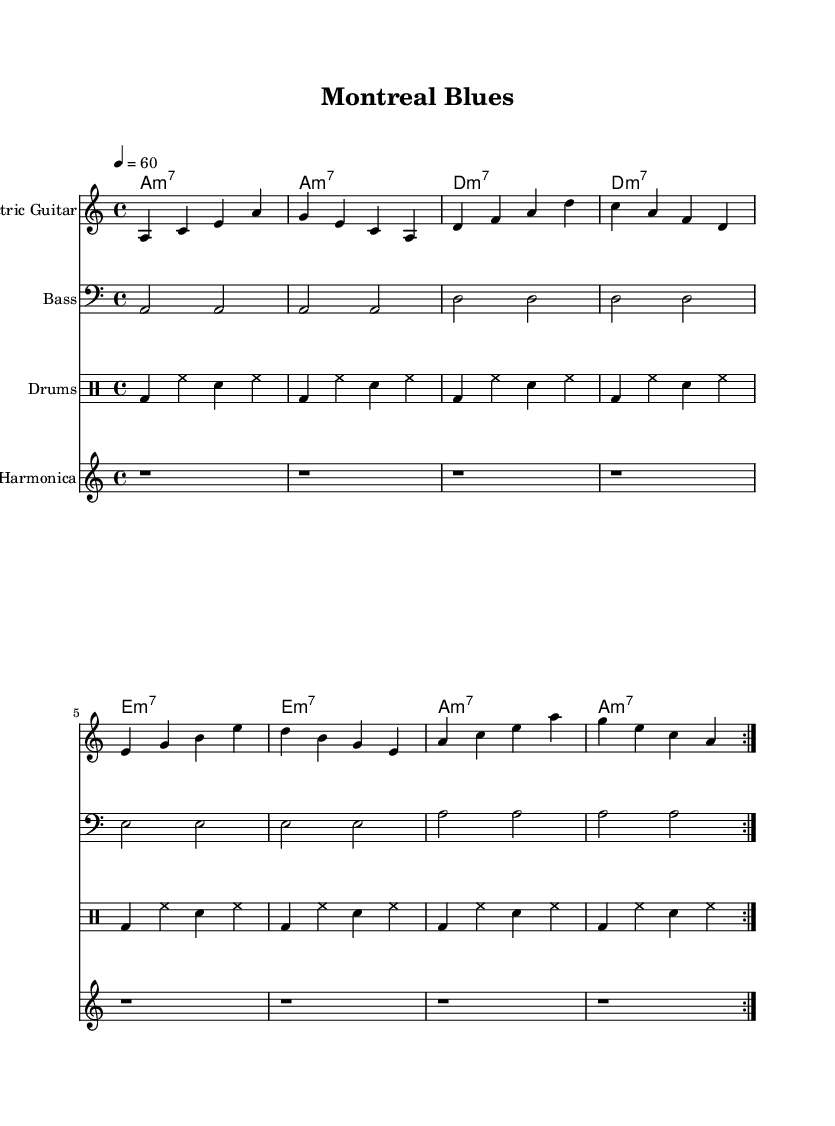What is the key signature of this music? The key signature is A minor, which is represented by no sharps or flats in the transversal lines of the staff. A minor is the relative minor of C major.
Answer: A minor What is the time signature of this piece? The time signature is 4/4, which means there are four beats in each measure and the quarter note gets one beat. This is indicated in the upper left section of the sheet music.
Answer: 4/4 What is the tempo marking for this piece? The tempo marking indicates a speed of 60 beats per minute, which is also specified in the upper section next to the tempo indication. It is shown with "4 = 60," meaning there are 60 quarter notes per minute.
Answer: 60 How many measures are repeated in the electric guitar part? The electric guitar part has a repeated section that is indicated by the "volta" markings, representing the section to be played twice. Counting the bars in the repeated section, we see that it consists of 8 measures.
Answer: 2 What type of guitar chord is primarily used in this piece? The primary guitar chord is A minor 7, which is indicated next to the chord symbols. The sheet music shows A minor 7 as the main chord throughout the piece.
Answer: A minor 7 What instrument accompanies the electric guitar in the rhythm section? The rhythm section includes a bass guitar, which is indicated in the lower staff just below the electric guitar. The bass guitar typically provides the harmonic foundation and complements the electric guitar's lead.
Answer: Bass How many beats per measure does the drum pattern follow? The drum pattern follows the same time signature as the piece, which is 4/4. This means that there are four beats in each measure of the drum pattern as well, aligning with the prescribed 4/4 time signature.
Answer: 4 